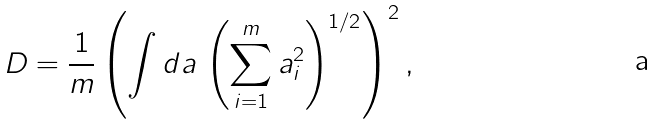Convert formula to latex. <formula><loc_0><loc_0><loc_500><loc_500>D = \frac { 1 } { m } \left ( \int d a \, \left ( \sum _ { i = 1 } ^ { m } a _ { i } ^ { 2 } \right ) ^ { 1 / 2 } \right ) ^ { 2 } ,</formula> 